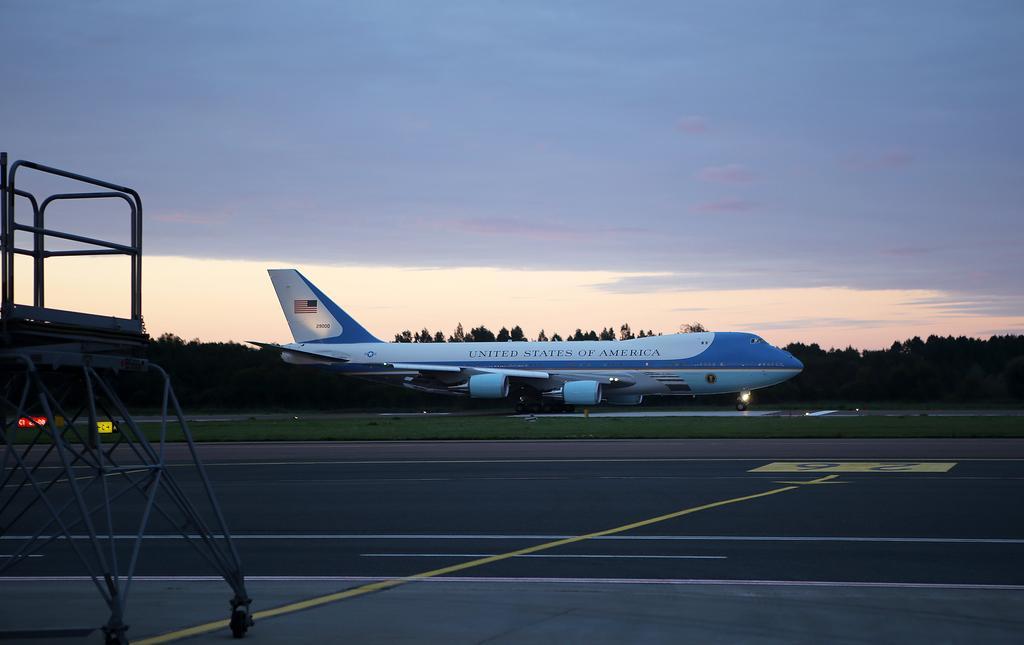Can you describe this image briefly? In this picture we can see the road, stand, grass, airplane, trees and some objects and in the background we can see the sky. 